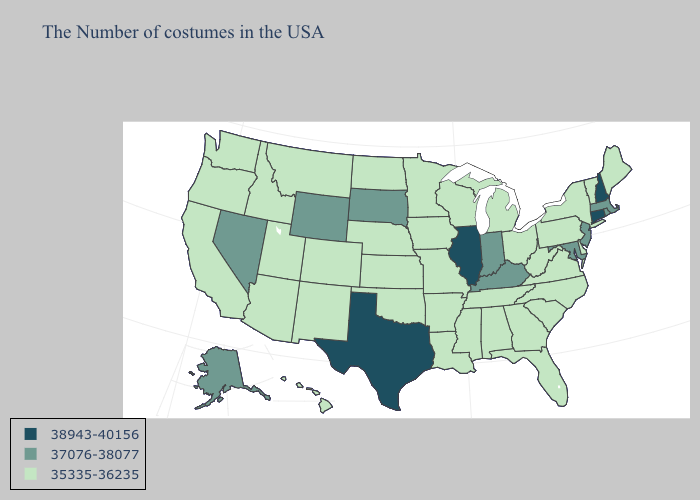What is the value of Montana?
Keep it brief. 35335-36235. Does New Jersey have the highest value in the USA?
Keep it brief. No. Name the states that have a value in the range 35335-36235?
Answer briefly. Maine, Vermont, New York, Delaware, Pennsylvania, Virginia, North Carolina, South Carolina, West Virginia, Ohio, Florida, Georgia, Michigan, Alabama, Tennessee, Wisconsin, Mississippi, Louisiana, Missouri, Arkansas, Minnesota, Iowa, Kansas, Nebraska, Oklahoma, North Dakota, Colorado, New Mexico, Utah, Montana, Arizona, Idaho, California, Washington, Oregon, Hawaii. Does Georgia have the lowest value in the South?
Write a very short answer. Yes. What is the lowest value in states that border Kansas?
Answer briefly. 35335-36235. What is the value of Oklahoma?
Concise answer only. 35335-36235. What is the highest value in the USA?
Give a very brief answer. 38943-40156. What is the highest value in states that border Arizona?
Write a very short answer. 37076-38077. Does Nebraska have the highest value in the USA?
Write a very short answer. No. Which states have the lowest value in the USA?
Keep it brief. Maine, Vermont, New York, Delaware, Pennsylvania, Virginia, North Carolina, South Carolina, West Virginia, Ohio, Florida, Georgia, Michigan, Alabama, Tennessee, Wisconsin, Mississippi, Louisiana, Missouri, Arkansas, Minnesota, Iowa, Kansas, Nebraska, Oklahoma, North Dakota, Colorado, New Mexico, Utah, Montana, Arizona, Idaho, California, Washington, Oregon, Hawaii. What is the value of Arkansas?
Quick response, please. 35335-36235. What is the value of Pennsylvania?
Concise answer only. 35335-36235. Does Idaho have a lower value than South Dakota?
Keep it brief. Yes. Name the states that have a value in the range 35335-36235?
Answer briefly. Maine, Vermont, New York, Delaware, Pennsylvania, Virginia, North Carolina, South Carolina, West Virginia, Ohio, Florida, Georgia, Michigan, Alabama, Tennessee, Wisconsin, Mississippi, Louisiana, Missouri, Arkansas, Minnesota, Iowa, Kansas, Nebraska, Oklahoma, North Dakota, Colorado, New Mexico, Utah, Montana, Arizona, Idaho, California, Washington, Oregon, Hawaii. 